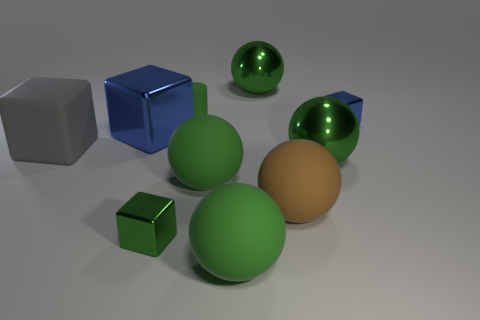What material is the cube that is the same color as the tiny cylinder?
Make the answer very short. Metal. What number of big objects are brown matte things or blue metallic blocks?
Keep it short and to the point. 2. There is a large brown rubber ball; how many big green things are left of it?
Keep it short and to the point. 3. The other small metal thing that is the same shape as the tiny blue thing is what color?
Your response must be concise. Green. How many metallic objects are purple balls or big blue things?
Your answer should be very brief. 1. Are there any small green rubber cylinders that are in front of the blue metallic object that is left of the tiny blue thing behind the big rubber cube?
Ensure brevity in your answer.  No. What color is the tiny matte object?
Offer a terse response. Green. There is a small metallic object in front of the big blue metal object; is its shape the same as the small blue shiny thing?
Offer a terse response. Yes. How many objects are either big gray rubber objects or tiny green things in front of the tiny blue metallic object?
Your answer should be compact. 2. Are the object in front of the green shiny block and the large gray object made of the same material?
Keep it short and to the point. Yes. 